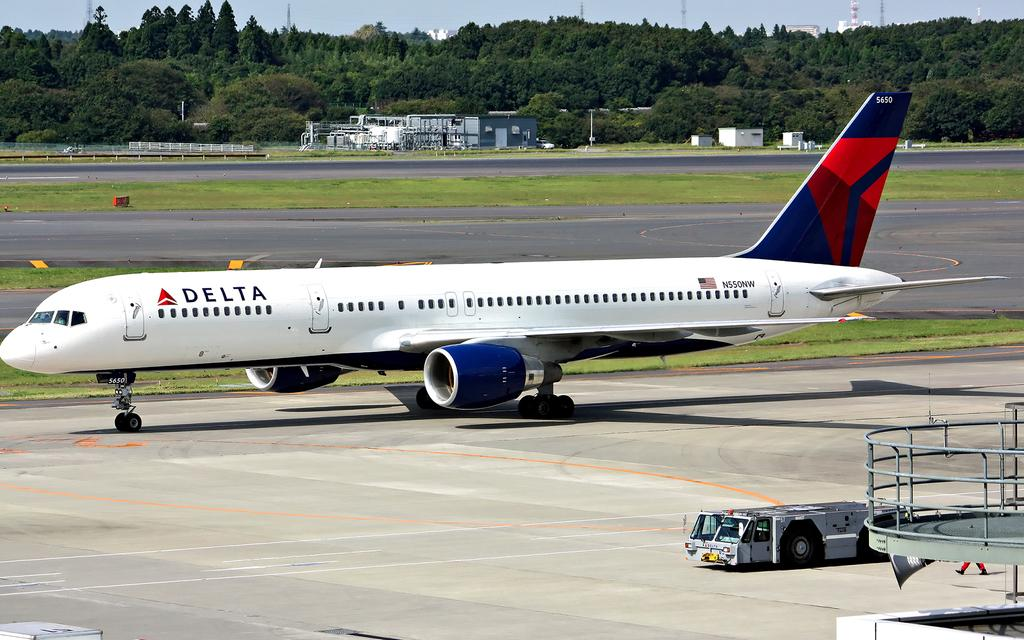Provide a one-sentence caption for the provided image. Delta airplane is not on the air but on the ground. 